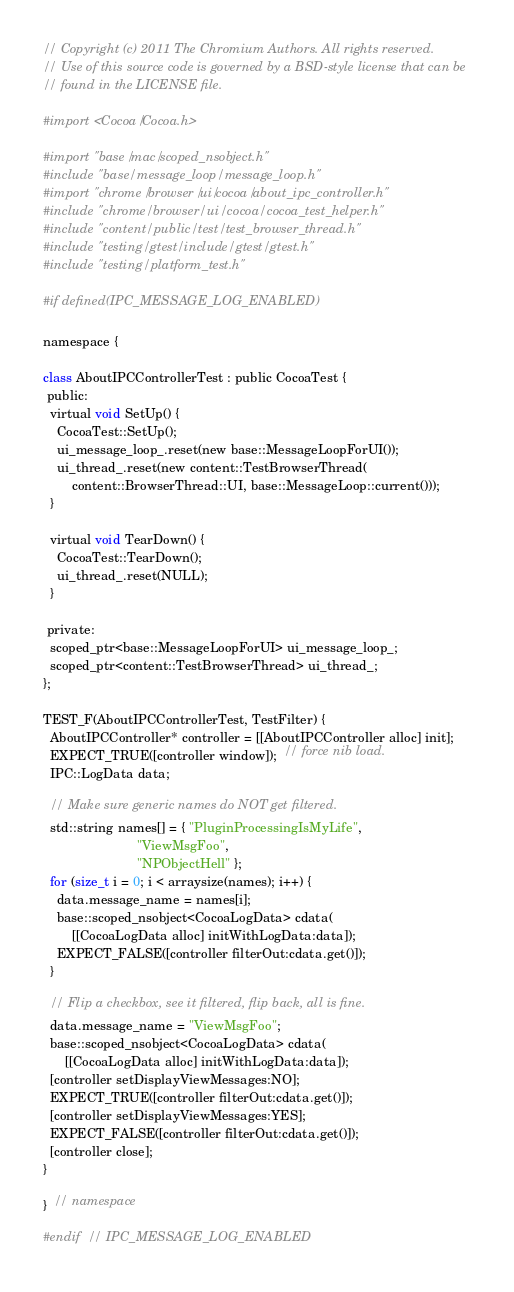<code> <loc_0><loc_0><loc_500><loc_500><_ObjectiveC_>// Copyright (c) 2011 The Chromium Authors. All rights reserved.
// Use of this source code is governed by a BSD-style license that can be
// found in the LICENSE file.

#import <Cocoa/Cocoa.h>

#import "base/mac/scoped_nsobject.h"
#include "base/message_loop/message_loop.h"
#import "chrome/browser/ui/cocoa/about_ipc_controller.h"
#include "chrome/browser/ui/cocoa/cocoa_test_helper.h"
#include "content/public/test/test_browser_thread.h"
#include "testing/gtest/include/gtest/gtest.h"
#include "testing/platform_test.h"

#if defined(IPC_MESSAGE_LOG_ENABLED)

namespace {

class AboutIPCControllerTest : public CocoaTest {
 public:
  virtual void SetUp() {
    CocoaTest::SetUp();
    ui_message_loop_.reset(new base::MessageLoopForUI());
    ui_thread_.reset(new content::TestBrowserThread(
        content::BrowserThread::UI, base::MessageLoop::current()));
  }

  virtual void TearDown() {
    CocoaTest::TearDown();
    ui_thread_.reset(NULL);
  }

 private:
  scoped_ptr<base::MessageLoopForUI> ui_message_loop_;
  scoped_ptr<content::TestBrowserThread> ui_thread_;
};

TEST_F(AboutIPCControllerTest, TestFilter) {
  AboutIPCController* controller = [[AboutIPCController alloc] init];
  EXPECT_TRUE([controller window]);  // force nib load.
  IPC::LogData data;

  // Make sure generic names do NOT get filtered.
  std::string names[] = { "PluginProcessingIsMyLife",
                          "ViewMsgFoo",
                          "NPObjectHell" };
  for (size_t i = 0; i < arraysize(names); i++) {
    data.message_name = names[i];
    base::scoped_nsobject<CocoaLogData> cdata(
        [[CocoaLogData alloc] initWithLogData:data]);
    EXPECT_FALSE([controller filterOut:cdata.get()]);
  }

  // Flip a checkbox, see it filtered, flip back, all is fine.
  data.message_name = "ViewMsgFoo";
  base::scoped_nsobject<CocoaLogData> cdata(
      [[CocoaLogData alloc] initWithLogData:data]);
  [controller setDisplayViewMessages:NO];
  EXPECT_TRUE([controller filterOut:cdata.get()]);
  [controller setDisplayViewMessages:YES];
  EXPECT_FALSE([controller filterOut:cdata.get()]);
  [controller close];
}

}  // namespace

#endif  // IPC_MESSAGE_LOG_ENABLED
</code> 